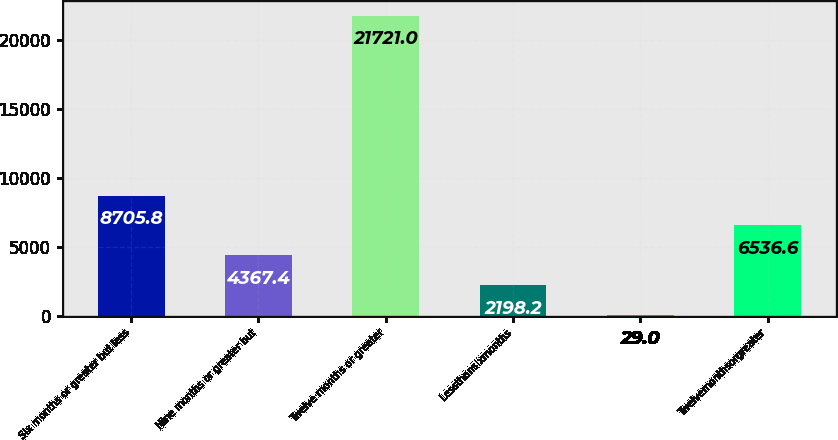<chart> <loc_0><loc_0><loc_500><loc_500><bar_chart><fcel>Six months or greater but less<fcel>Nine months or greater but<fcel>Twelve months or greater<fcel>Lessthansixmonths<fcel>Unnamed: 4<fcel>Twelvemonthsorgreater<nl><fcel>8705.8<fcel>4367.4<fcel>21721<fcel>2198.2<fcel>29<fcel>6536.6<nl></chart> 